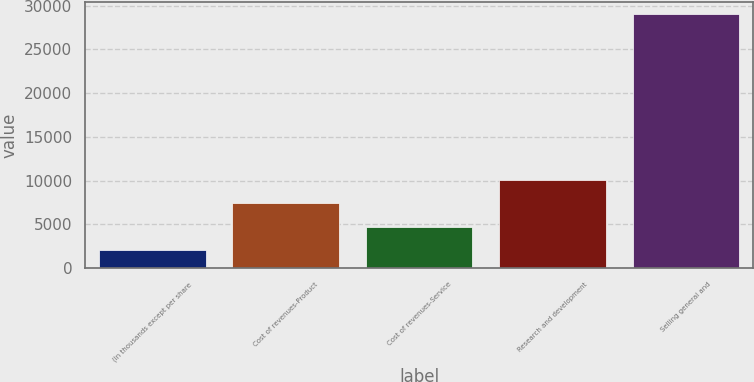Convert chart. <chart><loc_0><loc_0><loc_500><loc_500><bar_chart><fcel>(In thousands except per share<fcel>Cost of revenues-Product<fcel>Cost of revenues-Service<fcel>Research and development<fcel>Selling general and<nl><fcel>2009<fcel>7404.2<fcel>4706.6<fcel>10101.8<fcel>28985<nl></chart> 